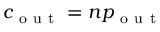Convert formula to latex. <formula><loc_0><loc_0><loc_500><loc_500>c _ { o u t } = n p _ { o u t }</formula> 